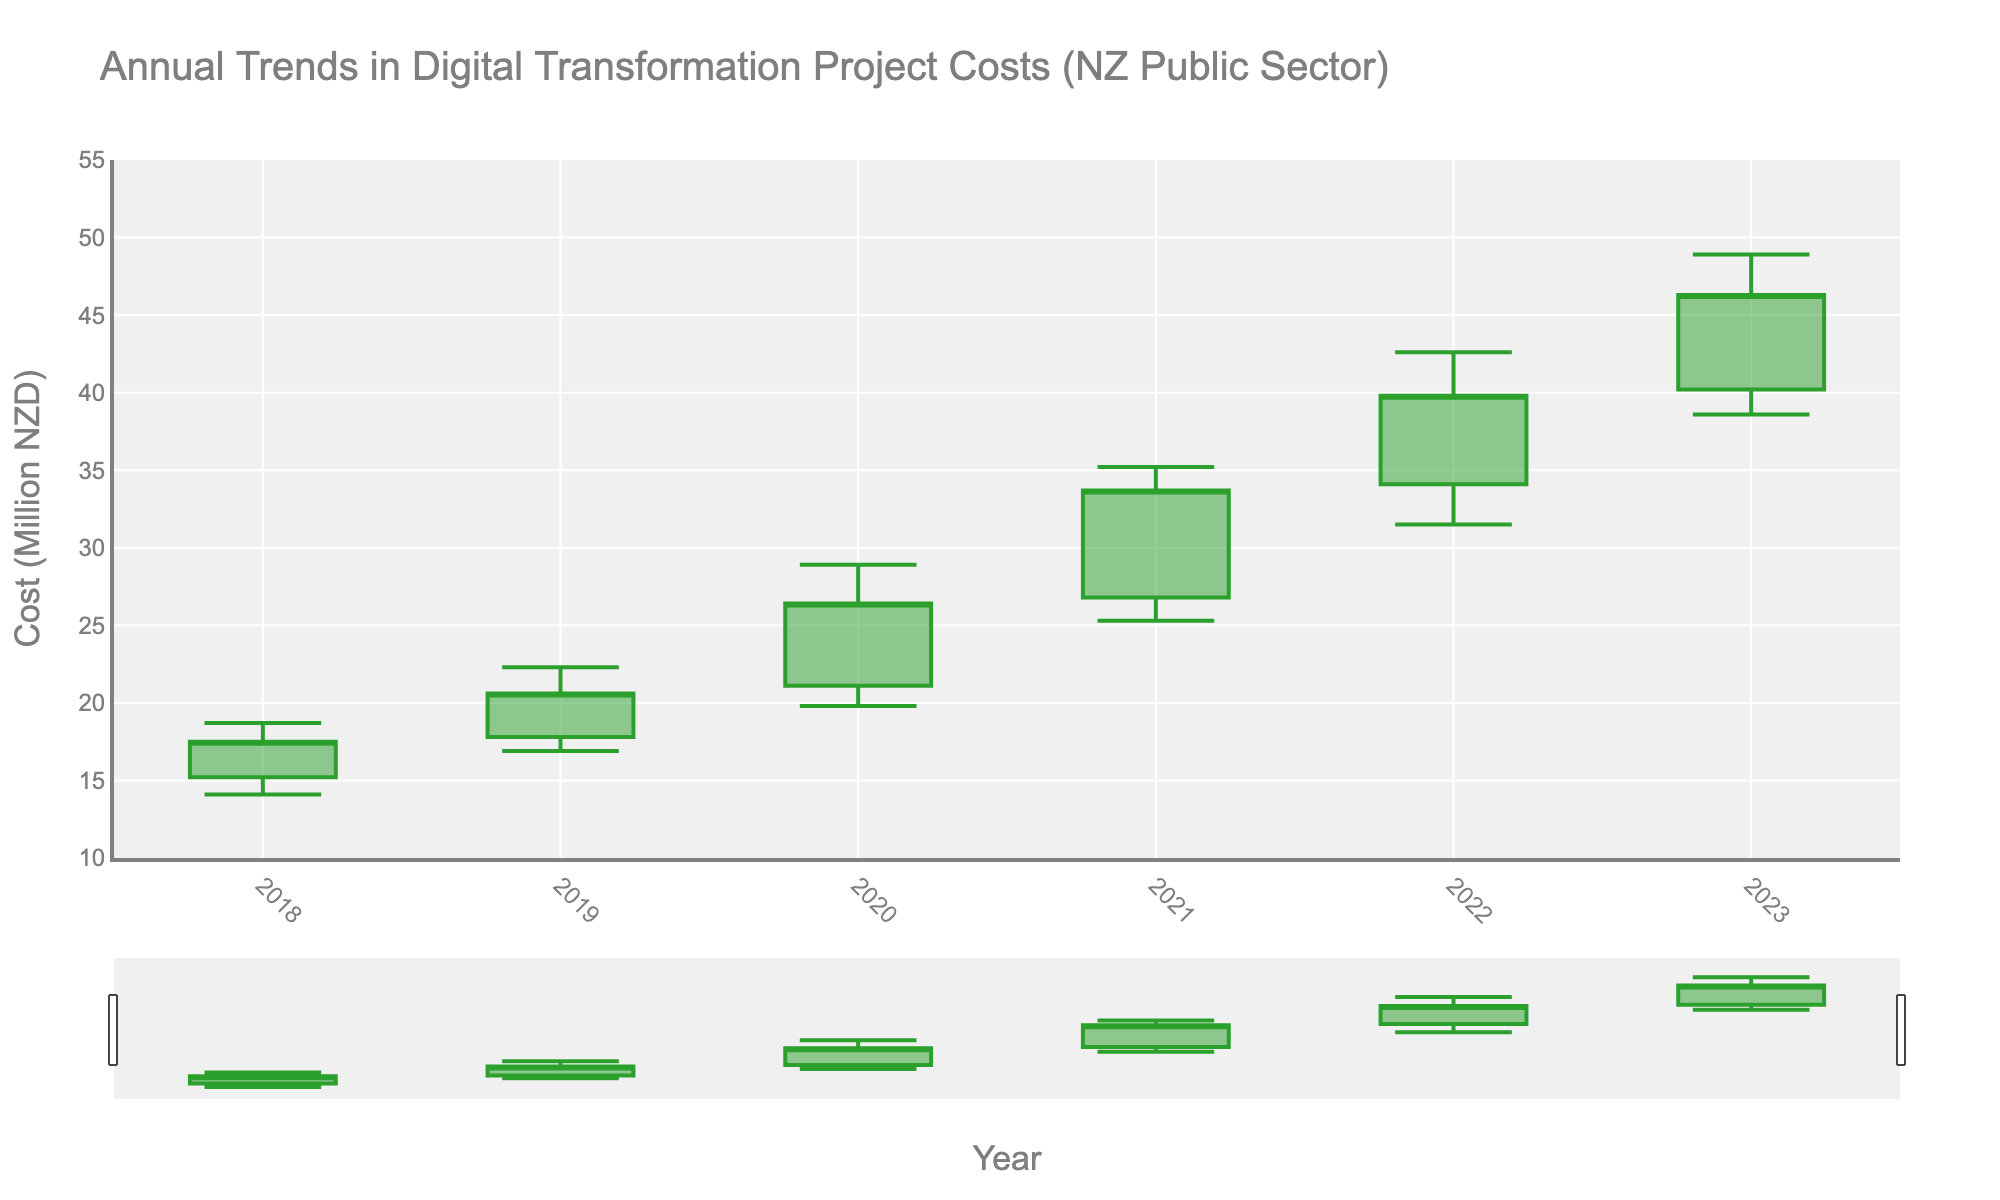What's the title of the chart? The title is normally displayed at the top of the chart, indicating what the chart represents. In this case, it is related to the annual trends in project costs within the New Zealand public sector.
Answer: Annual Trends in Digital Transformation Project Costs (NZ Public Sector) What is the highest cost recorded in the chart, and in which year? The highest cost recorded is shown as the maximum point in the "High" values. By examining the chart, we see the highest cost was in the year 2023.
Answer: 48.9 million NZD (2023) What is the trend of the opening digital transformation project costs over the years? The opening costs are plotted at the beginning value of each year. By looking at the position of the open values for each year from 2018 to 2023, we can infer the increasing trend.
Answer: Increasing Which year experienced the smallest difference between the highest and lowest project costs? The difference between the highest and lowest project costs can be found by subtracting the low value from the high value for each year. Comparing these differences, we find that the smallest difference was in 2018 (18.7 - 14.1 = 4.6).
Answer: 2018 In which year did the project costs close the highest? The closing costs are the final recorded numbers for each year. By checking the close values, we see the highest close value is in 2023.
Answer: 2023 How much did the closing project cost increase from 2019 to 2020? To find the increase, subtract the 2019 close value from the 2020 close value. (26.4 - 20.6 = 5.8)
Answer: 5.8 million NZD Was there any year where the low project cost was higher than the previous year's closing cost? Compare the low values of each year to the close values of the previous year. We find that the low of 2019 (16.9) is higher than the close of 2018 (17.5), and the low of 2020 (19.8) is higher than the close of 2019 (20.6).
Answer: Yes, 2020 Compare the opening costs in 2021 and 2022. Which year had a higher opening cost? By comparing the open values of 2021 (26.8) and 2022 (34.1), we identify that 2022 had a higher opening cost.
Answer: 2022 